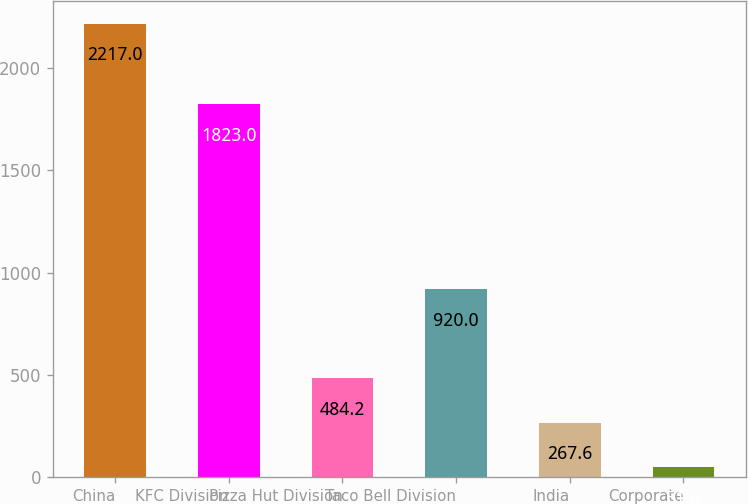Convert chart to OTSL. <chart><loc_0><loc_0><loc_500><loc_500><bar_chart><fcel>China<fcel>KFC Division<fcel>Pizza Hut Division<fcel>Taco Bell Division<fcel>India<fcel>Corporate<nl><fcel>2217<fcel>1823<fcel>484.2<fcel>920<fcel>267.6<fcel>51<nl></chart> 